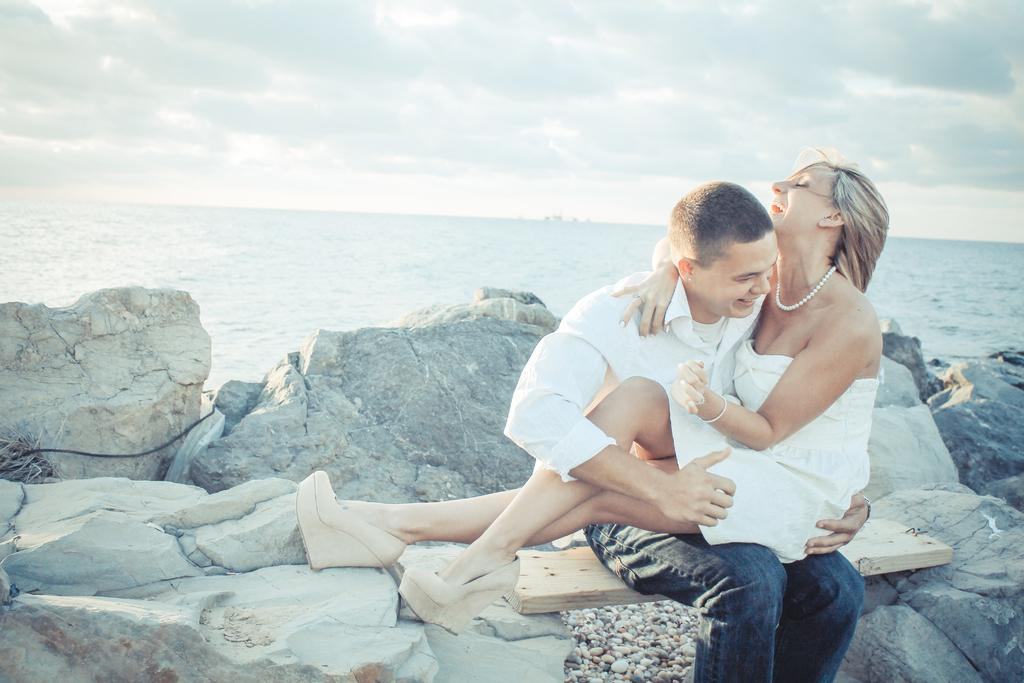What is the person sitting on in the image? The person is sitting on a wooden surface. How is the wooden surface supported in the image? The wooden surface is placed on rocks. What is the person doing with the woman in the image? The person is holding a woman. What can be seen in the background of the image? There is water visible in the background. Where can the person buy a bowl of soup in the image? There is no shop or mention of soup in the image. 